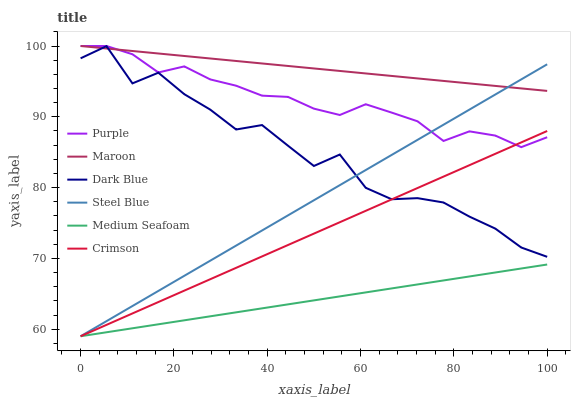Does Medium Seafoam have the minimum area under the curve?
Answer yes or no. Yes. Does Maroon have the maximum area under the curve?
Answer yes or no. Yes. Does Steel Blue have the minimum area under the curve?
Answer yes or no. No. Does Steel Blue have the maximum area under the curve?
Answer yes or no. No. Is Medium Seafoam the smoothest?
Answer yes or no. Yes. Is Dark Blue the roughest?
Answer yes or no. Yes. Is Steel Blue the smoothest?
Answer yes or no. No. Is Steel Blue the roughest?
Answer yes or no. No. Does Steel Blue have the lowest value?
Answer yes or no. Yes. Does Maroon have the lowest value?
Answer yes or no. No. Does Maroon have the highest value?
Answer yes or no. Yes. Does Steel Blue have the highest value?
Answer yes or no. No. Is Medium Seafoam less than Purple?
Answer yes or no. Yes. Is Purple greater than Medium Seafoam?
Answer yes or no. Yes. Does Dark Blue intersect Maroon?
Answer yes or no. Yes. Is Dark Blue less than Maroon?
Answer yes or no. No. Is Dark Blue greater than Maroon?
Answer yes or no. No. Does Medium Seafoam intersect Purple?
Answer yes or no. No. 